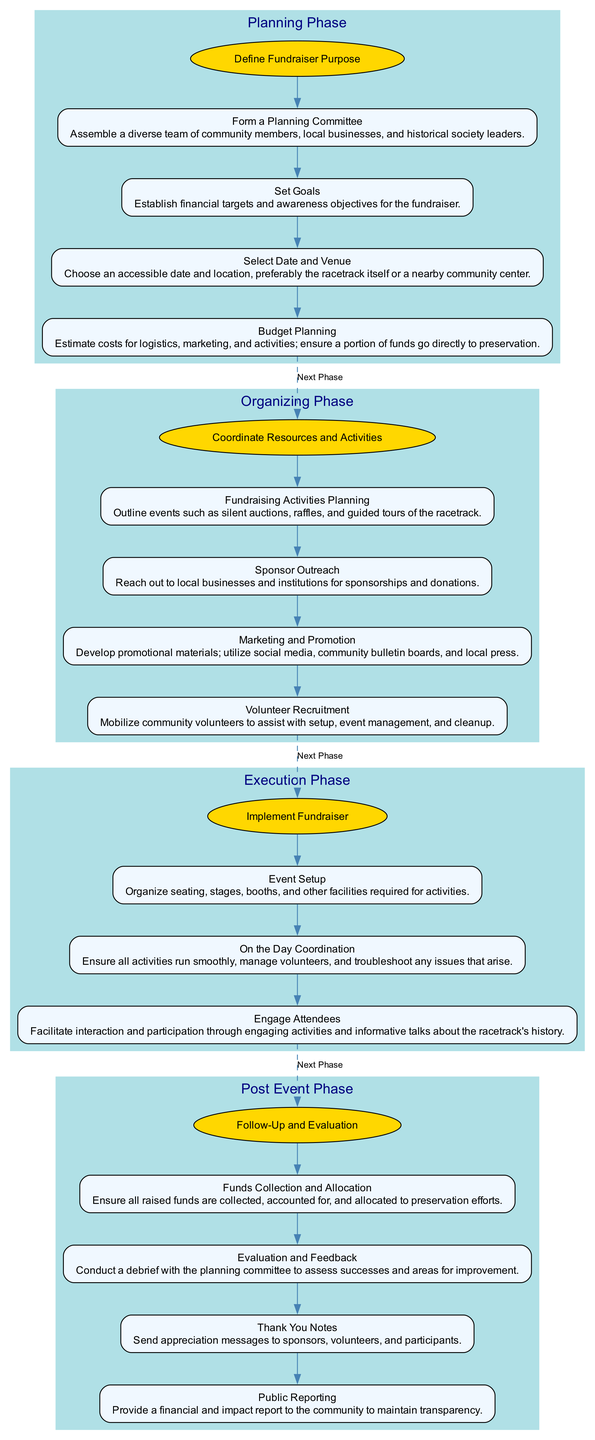What is the objective of the planning phase? The objective of the planning phase is explicitly stated in the diagram. It is the first node under the planning phase and is labeled as "Define Fundraiser Purpose."
Answer: Define Fundraiser Purpose How many steps are in the organizing phase? The organizing phase contains multiple steps, which can be counted directly from the diagram. There are four distinct steps listed under the organizing phase.
Answer: 4 What is the last task before transitioning to the execution phase? The last task before the transition is represented as the final step in the organizing phase. The corresponding task is "Marketing and Promotion." This step connects to the execution phase with a dashed edge indicating the next phase.
Answer: Marketing and Promotion What is the first task in the post-event phase? The first task is explicitly the first node under the post-event phase, listed as "Funds Collection and Allocation." This task initiates the follow-up process after the fundraiser.
Answer: Funds Collection and Allocation Which phase includes "Engage Attendees" as a task? By looking through the execution phase, "Engage Attendees" is specifically noted as one of the steps. It focuses on participating and interacting, crucial for the event's success.
Answer: Execution Phase Which task is responsible for reaching out to local businesses? In the organizing phase, the task titled "Sponsor Outreach" is explicitly focused on reaching out for sponsorships and donations, as indicated in the step description.
Answer: Sponsor Outreach What connects the execution and post-event phases? The connection between the execution and post-event phases is made through the last task in the execution phase, which is "On the Day Coordination." There's a dashed line indicating the flow to the next phase.
Answer: On the Day Coordination What is the purpose of the evaluation and feedback task? The "Evaluation and Feedback" task is to assess the outcomes of the fundraiser. It involves a debrief with the planning committee to identify successes and areas for improvement, fulfilling the goal of reflection post-event.
Answer: Evaluate successes How many tasks are listed in the execution phase? By reviewing the execution phase, there are three tasks numbered under it, indicating the specific actions that need to be taken during the implementation of the event.
Answer: 3 